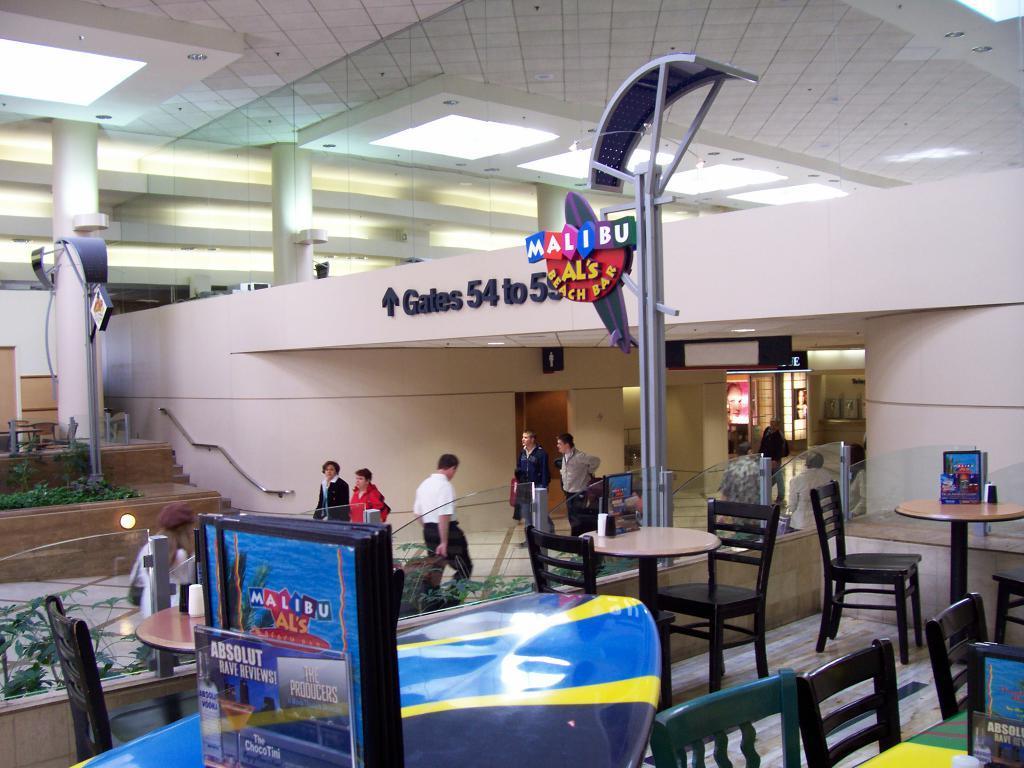How would you summarize this image in a sentence or two? Here we can see number of tables and chairs present and there are number of people working here and there and in the middle we can see hoarding as Malibu Al's beach bar and this is probably a beach bar 